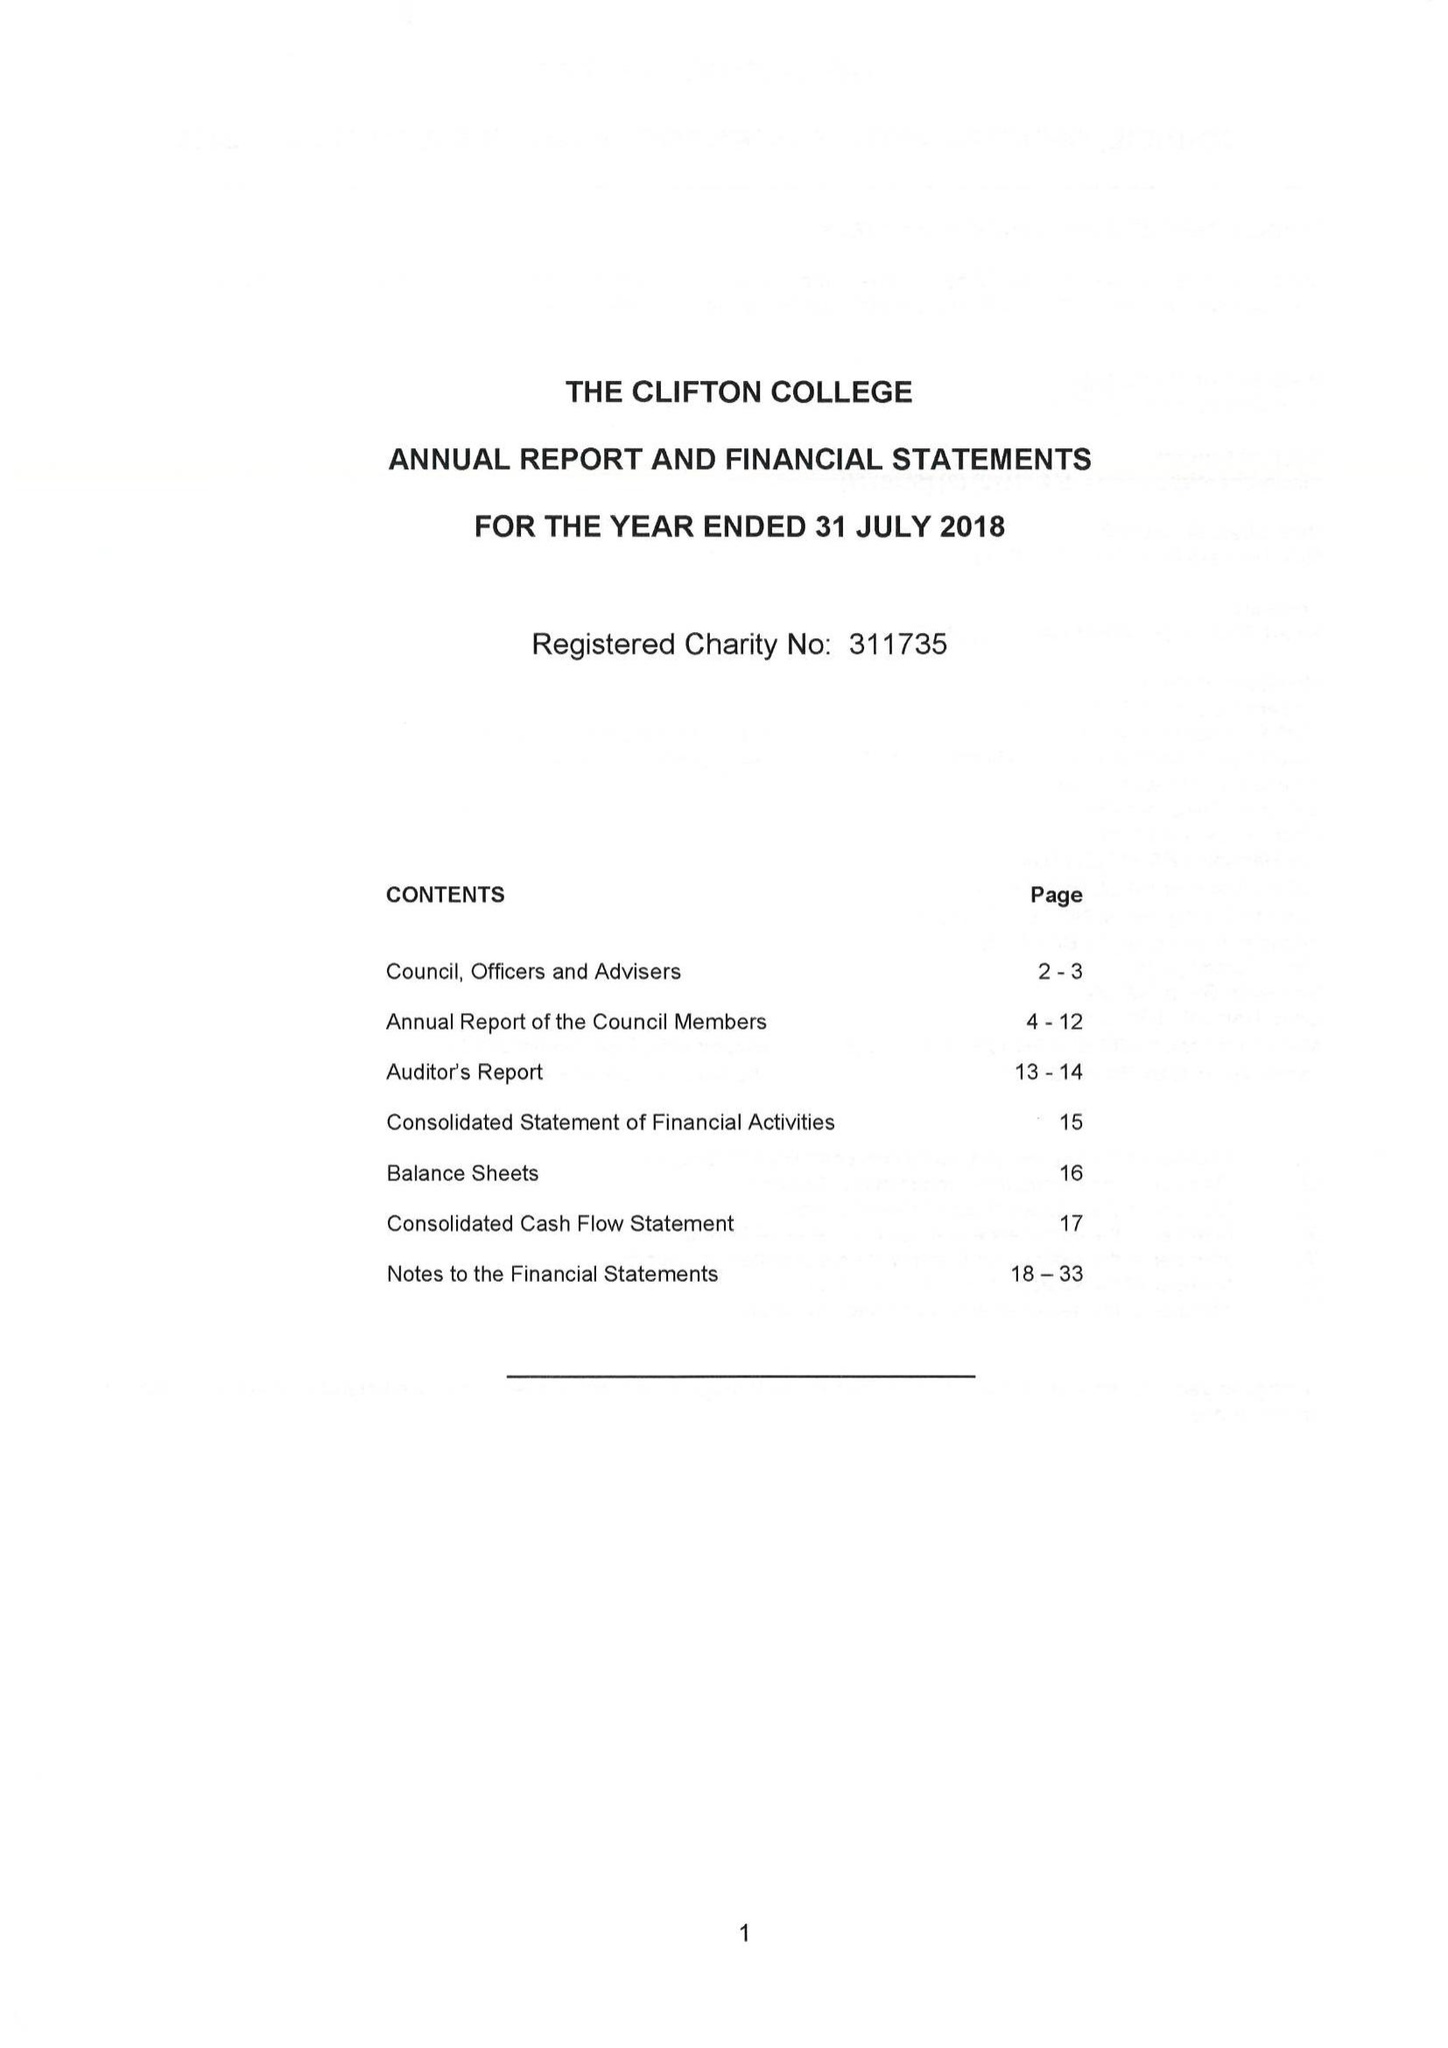What is the value for the charity_name?
Answer the question using a single word or phrase. Clifton College 